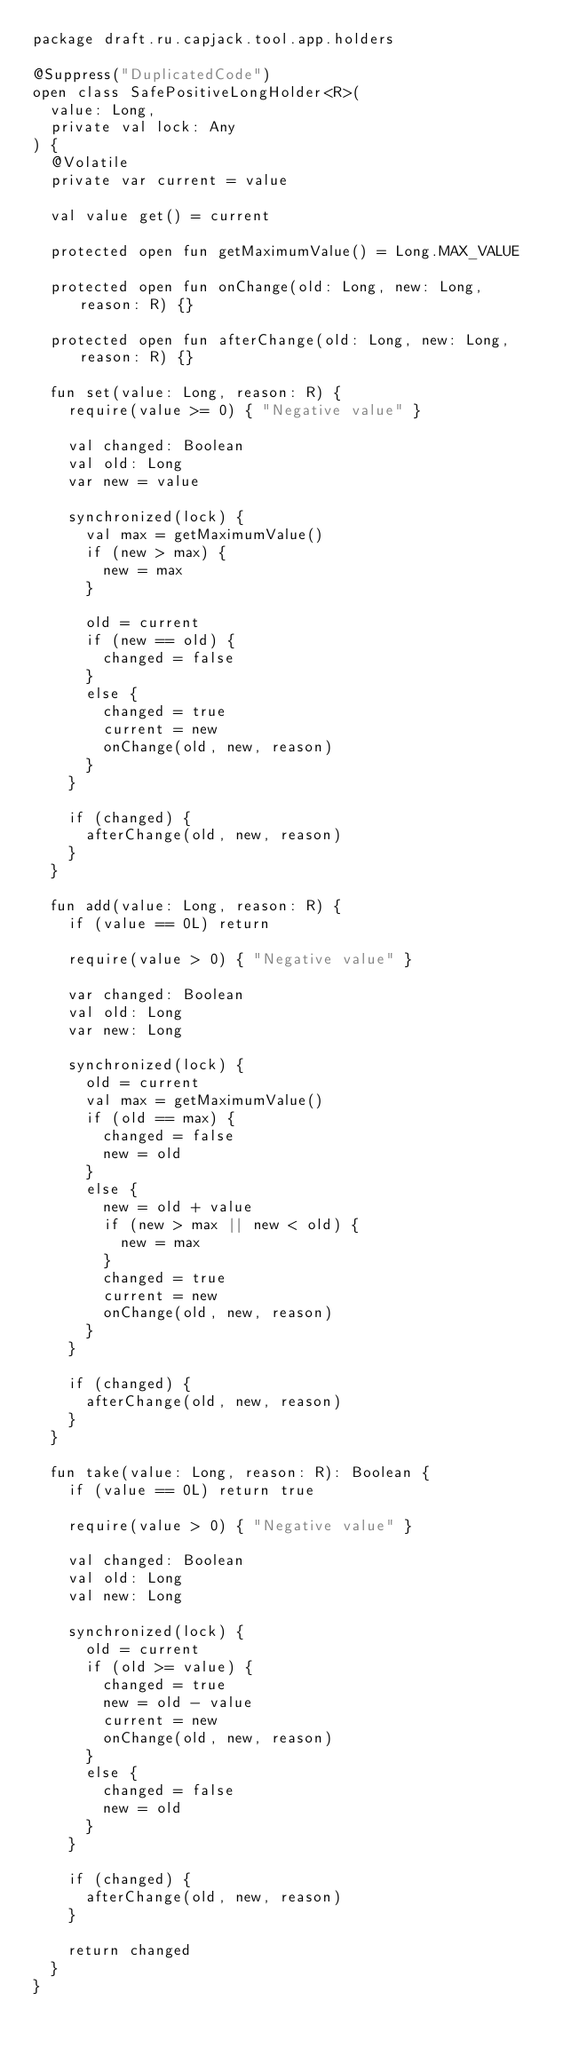<code> <loc_0><loc_0><loc_500><loc_500><_Kotlin_>package draft.ru.capjack.tool.app.holders

@Suppress("DuplicatedCode")
open class SafePositiveLongHolder<R>(
	value: Long,
	private val lock: Any
) {
	@Volatile
	private var current = value
	
	val value get() = current
	
	protected open fun getMaximumValue() = Long.MAX_VALUE
	
	protected open fun onChange(old: Long, new: Long, reason: R) {}
	
	protected open fun afterChange(old: Long, new: Long, reason: R) {}
	
	fun set(value: Long, reason: R) {
		require(value >= 0) { "Negative value" }
		
		val changed: Boolean
		val old: Long
		var new = value
		
		synchronized(lock) {
			val max = getMaximumValue()
			if (new > max) {
				new = max
			}
			
			old = current
			if (new == old) {
				changed = false
			}
			else {
				changed = true
				current = new
				onChange(old, new, reason)
			}
		}
		
		if (changed) {
			afterChange(old, new, reason)
		}
	}
	
	fun add(value: Long, reason: R) {
		if (value == 0L) return
		
		require(value > 0) { "Negative value" }
		
		var changed: Boolean
		val old: Long
		var new: Long
		
		synchronized(lock) {
			old = current
			val max = getMaximumValue()
			if (old == max) {
				changed = false
				new = old
			}
			else {
				new = old + value
				if (new > max || new < old) {
					new = max
				}
				changed = true
				current = new
				onChange(old, new, reason)
			}
		}
		
		if (changed) {
			afterChange(old, new, reason)
		}
	}
	
	fun take(value: Long, reason: R): Boolean {
		if (value == 0L) return true
		
		require(value > 0) { "Negative value" }
		
		val changed: Boolean
		val old: Long
		val new: Long
		
		synchronized(lock) {
			old = current
			if (old >= value) {
				changed = true
				new = old - value
				current = new
				onChange(old, new, reason)
			}
			else {
				changed = false
				new = old
			}
		}
		
		if (changed) {
			afterChange(old, new, reason)
		}
		
		return changed
	}
}</code> 